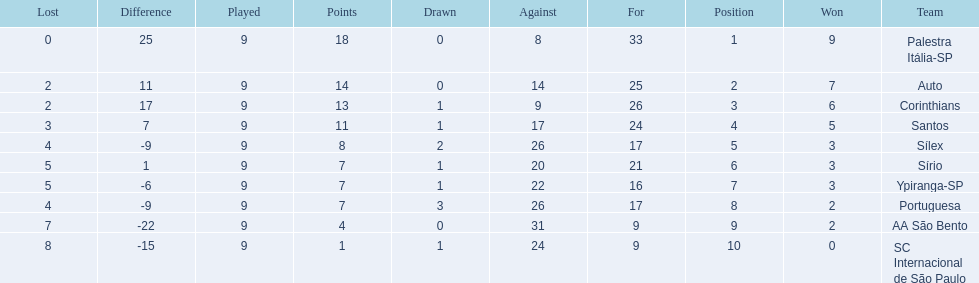Brazilian football in 1926 what teams had no draws? Palestra Itália-SP, Auto, AA São Bento. Of the teams with no draws name the 2 who lost the lease. Palestra Itália-SP, Auto. What team of the 2 who lost the least and had no draws had the highest difference? Palestra Itália-SP. 